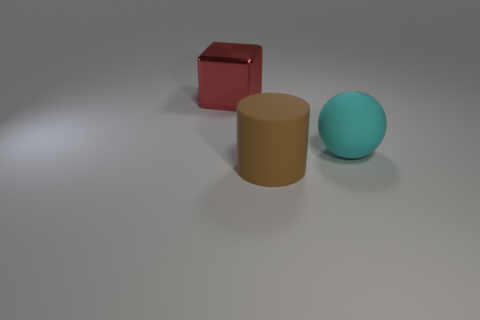Are there any other things that are the same material as the large block?
Your answer should be very brief. No. How many tiny things are either red metal blocks or cyan balls?
Provide a succinct answer. 0. Is the number of big red metal objects in front of the big brown object less than the number of cyan rubber things in front of the metal object?
Offer a terse response. Yes. What number of things are big objects or big brown metal cylinders?
Ensure brevity in your answer.  3. There is a red cube; what number of metal blocks are to the right of it?
Your answer should be compact. 0. Is the color of the big shiny object the same as the rubber cylinder?
Your response must be concise. No. There is a big object that is made of the same material as the large cylinder; what is its shape?
Provide a short and direct response. Sphere. There is a object to the left of the big brown matte cylinder; does it have the same shape as the brown object?
Keep it short and to the point. No. How many yellow objects are small rubber cubes or rubber cylinders?
Your answer should be compact. 0. Are there an equal number of large cylinders that are right of the large matte cylinder and cyan balls behind the rubber sphere?
Your answer should be very brief. Yes. 